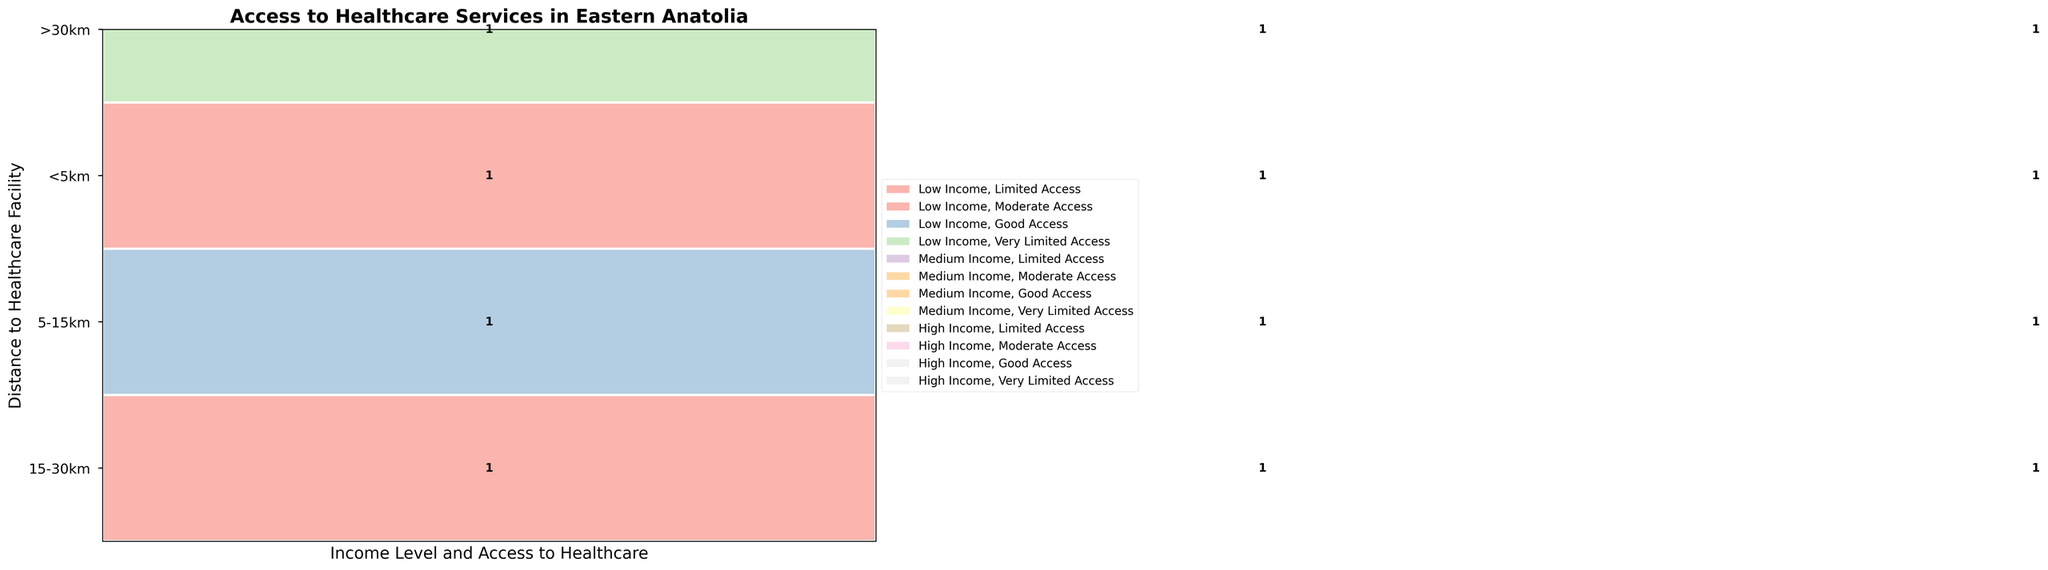How is access to healthcare services for households located less than 5km from a facility? Identify the data category '<5km', then observe the segments representing each income level and their color-coded access categories. Households close to facilities have access ranging from limited (low income) to good (high income).
Answer: Limited to Good Which distance category shows the worst access for low-income households? Check the data category for low income across all distances. The worst access is represented by the color coding. 'Extremely Poor' access appears in the '>30km' category.
Answer: >30km What is the distribution of access for medium-income households living 5-15km from a healthcare facility? Look at the 5-15km distance category, then identify the segments for medium-income households and their corresponding access levels. They have varied access levels marked as 'Limited'.
Answer: Limited Do high-income households consistently have better access than low-income households across all distance categories? Compare each distance category, looking at the segments for low and high-income households and assess their access levels. In general, high-income households tend to have better access, but exceptions exist at larger distances.
Answer: Generally yes, but with exceptions Which distance range has the most uniform access levels across different incomes? Observe all distance categories and look for the one where income levels do not dramatically change the access levels. The 5-15km category shows relatively consistent access levels across different incomes.
Answer: 5-15km How many distinct access categories are shown in the mosaic plot? Count the different color-coded access categories displayed in the figure. The categories visible include Limited, Moderate, Good, Very Limited, Poor, and Extremely Poor.
Answer: 6 For which distances do high-income households experience 'Moderate' access or better? Inspect each distance category and identify where high-income households have 'Moderate' or 'Good' access levels marked by specific colors. Less than 5km and 5-15km show better access for high-income households.
Answer: <5km and 5-15km Compare access to healthcare services for medium-income households located more than 30km away with high-income households at the same distance. Identify the '>30km' category, then compare the medium-income and high-income segments to determine their access levels. Medium-income households face 'Poor' access, while high-income have 'Very Limited' access.
Answer: Medium: Poor, High: Very Limited 